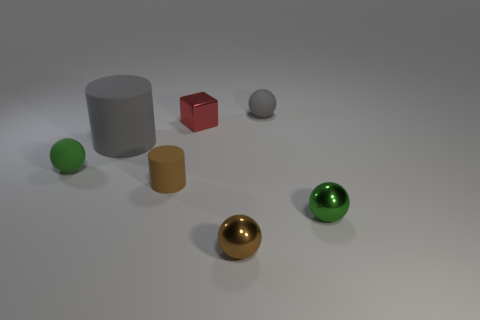Subtract all small brown spheres. How many spheres are left? 3 Add 2 tiny metallic things. How many objects exist? 9 Subtract all yellow cubes. How many green spheres are left? 2 Subtract 2 spheres. How many spheres are left? 2 Subtract all brown spheres. How many spheres are left? 3 Subtract all cubes. How many objects are left? 6 Subtract 1 gray balls. How many objects are left? 6 Subtract all yellow cubes. Subtract all red cylinders. How many cubes are left? 1 Subtract all small rubber cylinders. Subtract all gray rubber spheres. How many objects are left? 5 Add 7 tiny metallic cubes. How many tiny metallic cubes are left? 8 